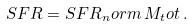<formula> <loc_0><loc_0><loc_500><loc_500>S F R = S F R _ { n } o r m \, M _ { t } o t \, .</formula> 